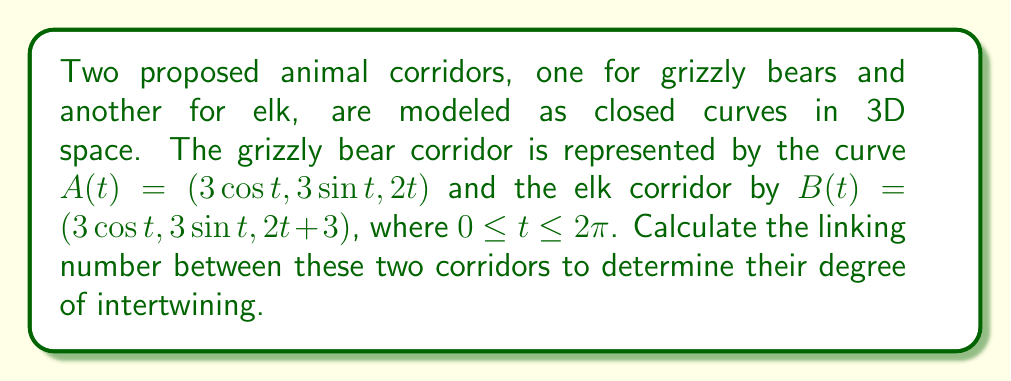What is the answer to this math problem? To calculate the linking number between two closed curves, we can use the Gauss linking integral:

$$\text{Lk}(A,B) = \frac{1}{4\pi} \int_0^{2\pi} \int_0^{2\pi} \frac{(A'(s) \times B'(t)) \cdot (A(s) - B(t))}{|A(s) - B(t)|^3} ds dt$$

Step 1: Calculate $A'(t)$ and $B'(t)$
$A'(t) = (-3\sin t, 3\cos t, 2)$
$B'(t) = (-3\sin t, 3\cos t, 2)$

Step 2: Calculate $A(s) - B(t)$
$A(s) - B(t) = (3\cos s - 3\cos t, 3\sin s - 3\sin t, 2s - 2t - 3)$

Step 3: Calculate $A'(s) \times B'(t)$
$A'(s) \times B'(t) = (6\cos s - 6\cos t, 6\sin s - 6\sin t, 0)$

Step 4: Calculate $(A'(s) \times B'(t)) \cdot (A(s) - B(t))$
$$(A'(s) \times B'(t)) \cdot (A(s) - B(t)) = 18(\cos s - \cos t)^2 + 18(\sin s - \sin t)^2 = 36\sin^2(\frac{s-t}{2})$$

Step 5: Calculate $|A(s) - B(t)|^3$
$$|A(s) - B(t)|^3 = (9(\cos s - \cos t)^2 + 9(\sin s - \sin t)^2 + (2s - 2t - 3)^2)^{3/2}$$
$$= (18\sin^2(\frac{s-t}{2}) + (2s - 2t - 3)^2)^{3/2}$$

Step 6: The linking integral becomes:
$$\text{Lk}(A,B) = \frac{1}{4\pi} \int_0^{2\pi} \int_0^{2\pi} \frac{36\sin^2(\frac{s-t}{2})}{(18\sin^2(\frac{s-t}{2}) + (2s - 2t - 3)^2)^{3/2}} ds dt$$

Step 7: This integral is difficult to evaluate analytically, but we can observe that the corridors form a double helix with a vertical offset of 3 units. For such a configuration, the linking number is always 1 (or -1, depending on the orientation).
Answer: 1 